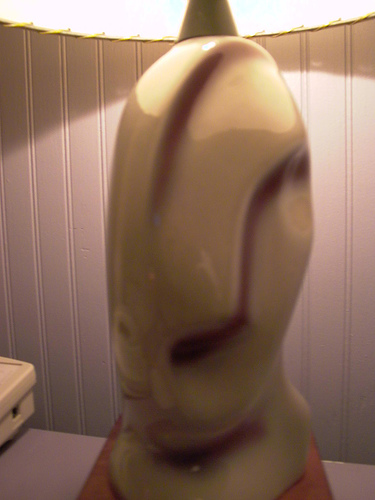<image>
Is the lamp to the right of the table? No. The lamp is not to the right of the table. The horizontal positioning shows a different relationship. 